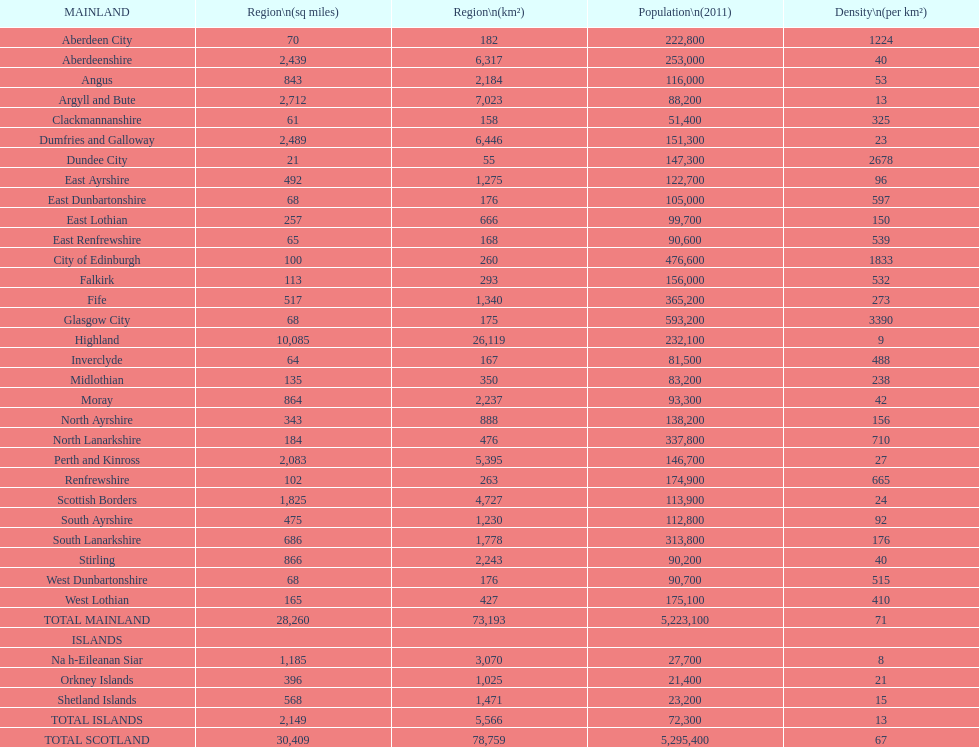What number of mainlands have populations under 100,000? 9. 